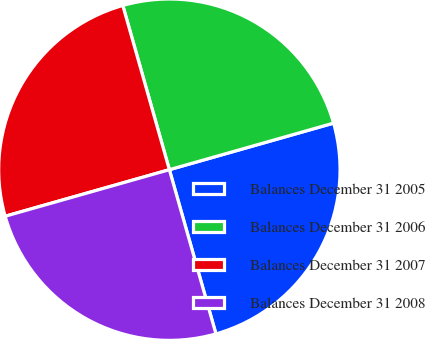Convert chart to OTSL. <chart><loc_0><loc_0><loc_500><loc_500><pie_chart><fcel>Balances December 31 2005<fcel>Balances December 31 2006<fcel>Balances December 31 2007<fcel>Balances December 31 2008<nl><fcel>25.0%<fcel>25.0%<fcel>25.0%<fcel>25.0%<nl></chart> 